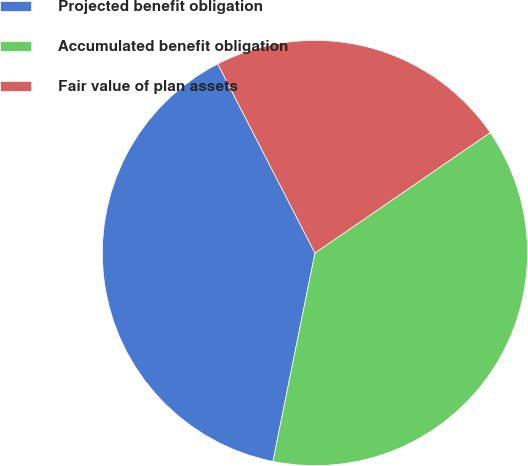Convert chart. <chart><loc_0><loc_0><loc_500><loc_500><pie_chart><fcel>Projected benefit obligation<fcel>Accumulated benefit obligation<fcel>Fair value of plan assets<nl><fcel>39.27%<fcel>37.75%<fcel>22.98%<nl></chart> 